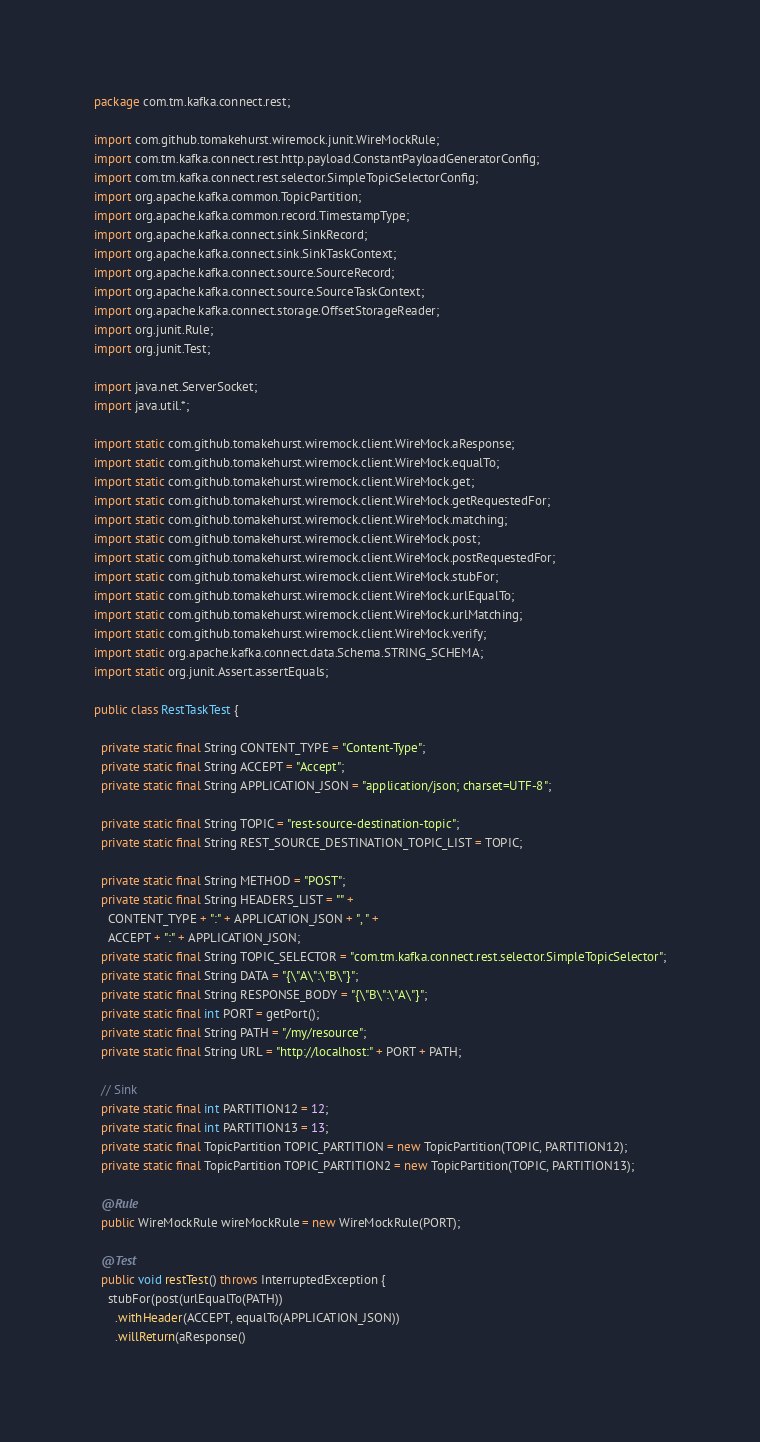<code> <loc_0><loc_0><loc_500><loc_500><_Java_>package com.tm.kafka.connect.rest;

import com.github.tomakehurst.wiremock.junit.WireMockRule;
import com.tm.kafka.connect.rest.http.payload.ConstantPayloadGeneratorConfig;
import com.tm.kafka.connect.rest.selector.SimpleTopicSelectorConfig;
import org.apache.kafka.common.TopicPartition;
import org.apache.kafka.common.record.TimestampType;
import org.apache.kafka.connect.sink.SinkRecord;
import org.apache.kafka.connect.sink.SinkTaskContext;
import org.apache.kafka.connect.source.SourceRecord;
import org.apache.kafka.connect.source.SourceTaskContext;
import org.apache.kafka.connect.storage.OffsetStorageReader;
import org.junit.Rule;
import org.junit.Test;

import java.net.ServerSocket;
import java.util.*;

import static com.github.tomakehurst.wiremock.client.WireMock.aResponse;
import static com.github.tomakehurst.wiremock.client.WireMock.equalTo;
import static com.github.tomakehurst.wiremock.client.WireMock.get;
import static com.github.tomakehurst.wiremock.client.WireMock.getRequestedFor;
import static com.github.tomakehurst.wiremock.client.WireMock.matching;
import static com.github.tomakehurst.wiremock.client.WireMock.post;
import static com.github.tomakehurst.wiremock.client.WireMock.postRequestedFor;
import static com.github.tomakehurst.wiremock.client.WireMock.stubFor;
import static com.github.tomakehurst.wiremock.client.WireMock.urlEqualTo;
import static com.github.tomakehurst.wiremock.client.WireMock.urlMatching;
import static com.github.tomakehurst.wiremock.client.WireMock.verify;
import static org.apache.kafka.connect.data.Schema.STRING_SCHEMA;
import static org.junit.Assert.assertEquals;

public class RestTaskTest {

  private static final String CONTENT_TYPE = "Content-Type";
  private static final String ACCEPT = "Accept";
  private static final String APPLICATION_JSON = "application/json; charset=UTF-8";

  private static final String TOPIC = "rest-source-destination-topic";
  private static final String REST_SOURCE_DESTINATION_TOPIC_LIST = TOPIC;

  private static final String METHOD = "POST";
  private static final String HEADERS_LIST = "" +
    CONTENT_TYPE + ":" + APPLICATION_JSON + ", " +
    ACCEPT + ":" + APPLICATION_JSON;
  private static final String TOPIC_SELECTOR = "com.tm.kafka.connect.rest.selector.SimpleTopicSelector";
  private static final String DATA = "{\"A\":\"B\"}";
  private static final String RESPONSE_BODY = "{\"B\":\"A\"}";
  private static final int PORT = getPort();
  private static final String PATH = "/my/resource";
  private static final String URL = "http://localhost:" + PORT + PATH;

  // Sink
  private static final int PARTITION12 = 12;
  private static final int PARTITION13 = 13;
  private static final TopicPartition TOPIC_PARTITION = new TopicPartition(TOPIC, PARTITION12);
  private static final TopicPartition TOPIC_PARTITION2 = new TopicPartition(TOPIC, PARTITION13);

  @Rule
  public WireMockRule wireMockRule = new WireMockRule(PORT);

  @Test
  public void restTest() throws InterruptedException {
    stubFor(post(urlEqualTo(PATH))
      .withHeader(ACCEPT, equalTo(APPLICATION_JSON))
      .willReturn(aResponse()</code> 